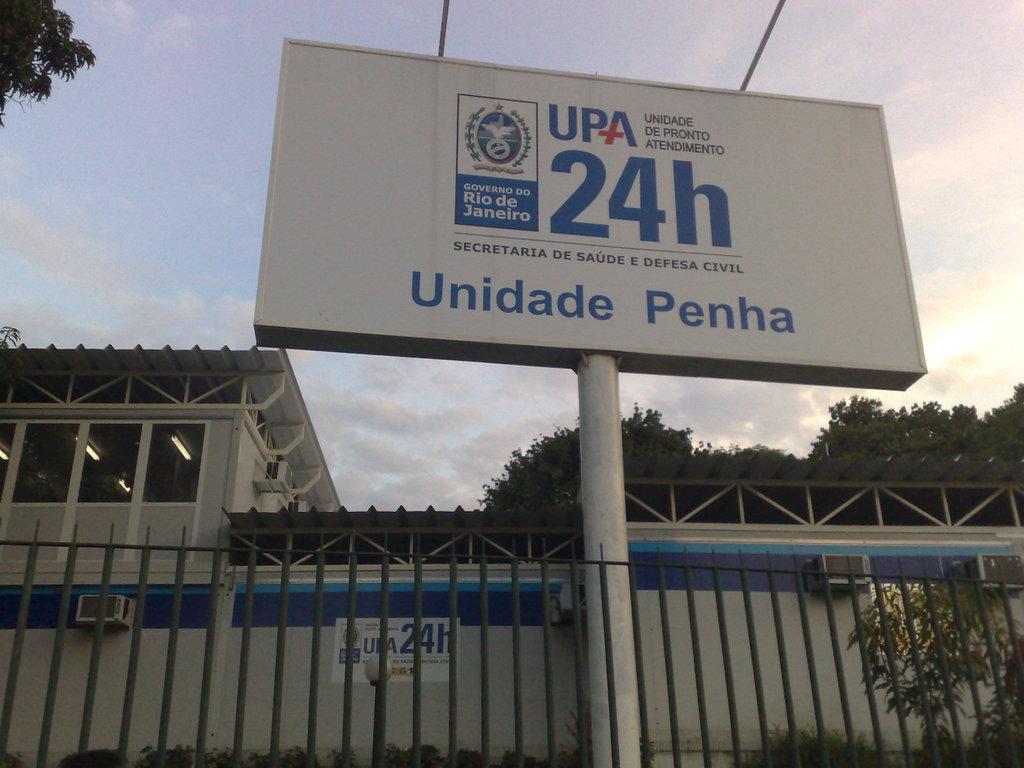What does this billboard tell you?
Ensure brevity in your answer.  Unidade penha. What city is shown on this sign?
Make the answer very short. Rio de janeiro. 